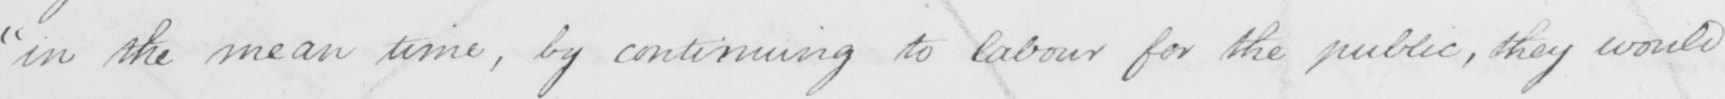Can you tell me what this handwritten text says? " in the mean time , by continuing to labour for the public , they would 